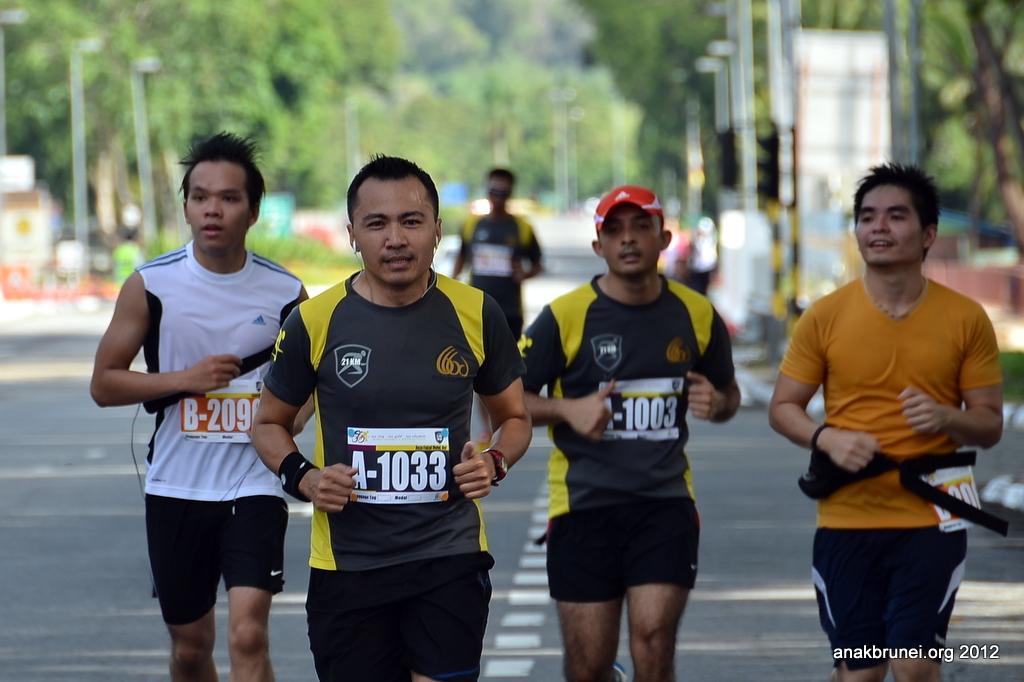Describe this image in one or two sentences. In this picture we can see group of people, they are running on the road, in the background we can see few poles, trees and hoardings. 